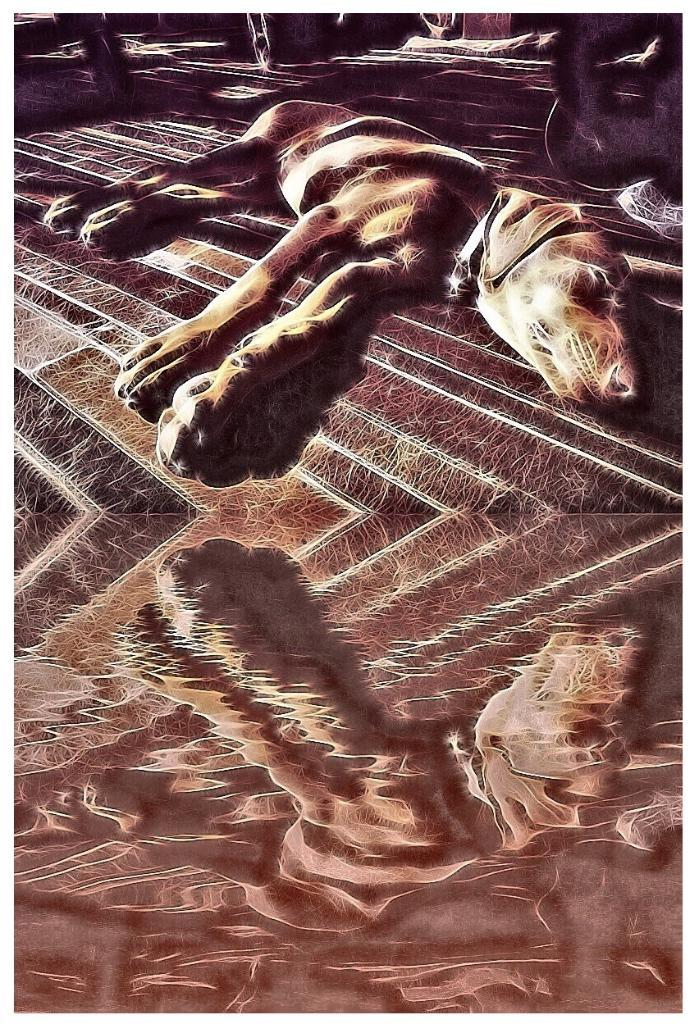What animal can be seen in the picture? There is a dog in the picture. What position is the dog in? The dog is lying on the floor. What type of flesh can be seen on the dog in the picture? There is no mention of any flesh in the image, and the dog's body is not described in detail. 